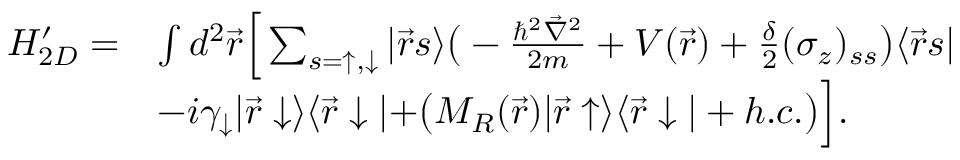<formula> <loc_0><loc_0><loc_500><loc_500>\begin{array} { r l } { H _ { 2 D } ^ { \prime } = } & { \int d ^ { 2 } \vec { r } \left [ \sum _ { s = \uparrow , \downarrow } | \vec { r } s \rangle \left ( - \frac { \hbar { ^ } { 2 } \vec { \nabla } ^ { 2 } } { 2 m } + V ( \vec { r } ) + \frac { \delta } { 2 } ( \sigma _ { z } ) _ { s s } \right ) \langle \vec { r } s | } \\ & { - i \gamma _ { \downarrow } | \vec { r } \downarrow \rangle \langle \vec { r } \downarrow | + \left ( M _ { R } ( \vec { r } ) | \vec { r } \uparrow \rangle \langle \vec { r } \downarrow | + h . c . \right ) \right ] . } \end{array}</formula> 